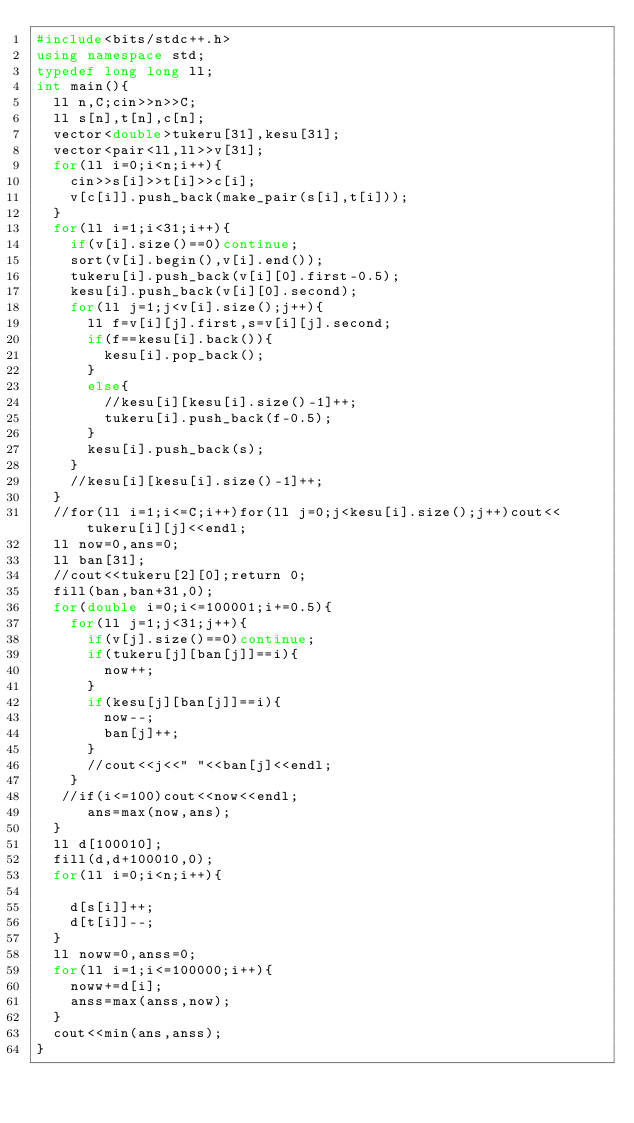Convert code to text. <code><loc_0><loc_0><loc_500><loc_500><_C++_>#include<bits/stdc++.h>
using namespace std;
typedef long long ll;
int main(){
  ll n,C;cin>>n>>C;
  ll s[n],t[n],c[n];
  vector<double>tukeru[31],kesu[31];
  vector<pair<ll,ll>>v[31];
  for(ll i=0;i<n;i++){
    cin>>s[i]>>t[i]>>c[i];
    v[c[i]].push_back(make_pair(s[i],t[i]));
  }
  for(ll i=1;i<31;i++){
    if(v[i].size()==0)continue;
    sort(v[i].begin(),v[i].end());
    tukeru[i].push_back(v[i][0].first-0.5);
    kesu[i].push_back(v[i][0].second);
    for(ll j=1;j<v[i].size();j++){
      ll f=v[i][j].first,s=v[i][j].second;
      if(f==kesu[i].back()){
        kesu[i].pop_back();
      }
      else{
        //kesu[i][kesu[i].size()-1]++;
        tukeru[i].push_back(f-0.5);
      }
      kesu[i].push_back(s);
    }
    //kesu[i][kesu[i].size()-1]++;
  }
  //for(ll i=1;i<=C;i++)for(ll j=0;j<kesu[i].size();j++)cout<<tukeru[i][j]<<endl;
  ll now=0,ans=0;
  ll ban[31];
  //cout<<tukeru[2][0];return 0;
  fill(ban,ban+31,0);
  for(double i=0;i<=100001;i+=0.5){
    for(ll j=1;j<31;j++){
      if(v[j].size()==0)continue;
      if(tukeru[j][ban[j]]==i){
        now++; 
      }
      if(kesu[j][ban[j]]==i){
        now--;
        ban[j]++;
      }
      //cout<<j<<" "<<ban[j]<<endl;
    }
   //if(i<=100)cout<<now<<endl;
      ans=max(now,ans);
  }
  ll d[100010];
  fill(d,d+100010,0);
  for(ll i=0;i<n;i++){
    
    d[s[i]]++;
    d[t[i]]--;
  }
  ll noww=0,anss=0;
  for(ll i=1;i<=100000;i++){
    noww+=d[i];
    anss=max(anss,now);
  }
  cout<<min(ans,anss);
}</code> 